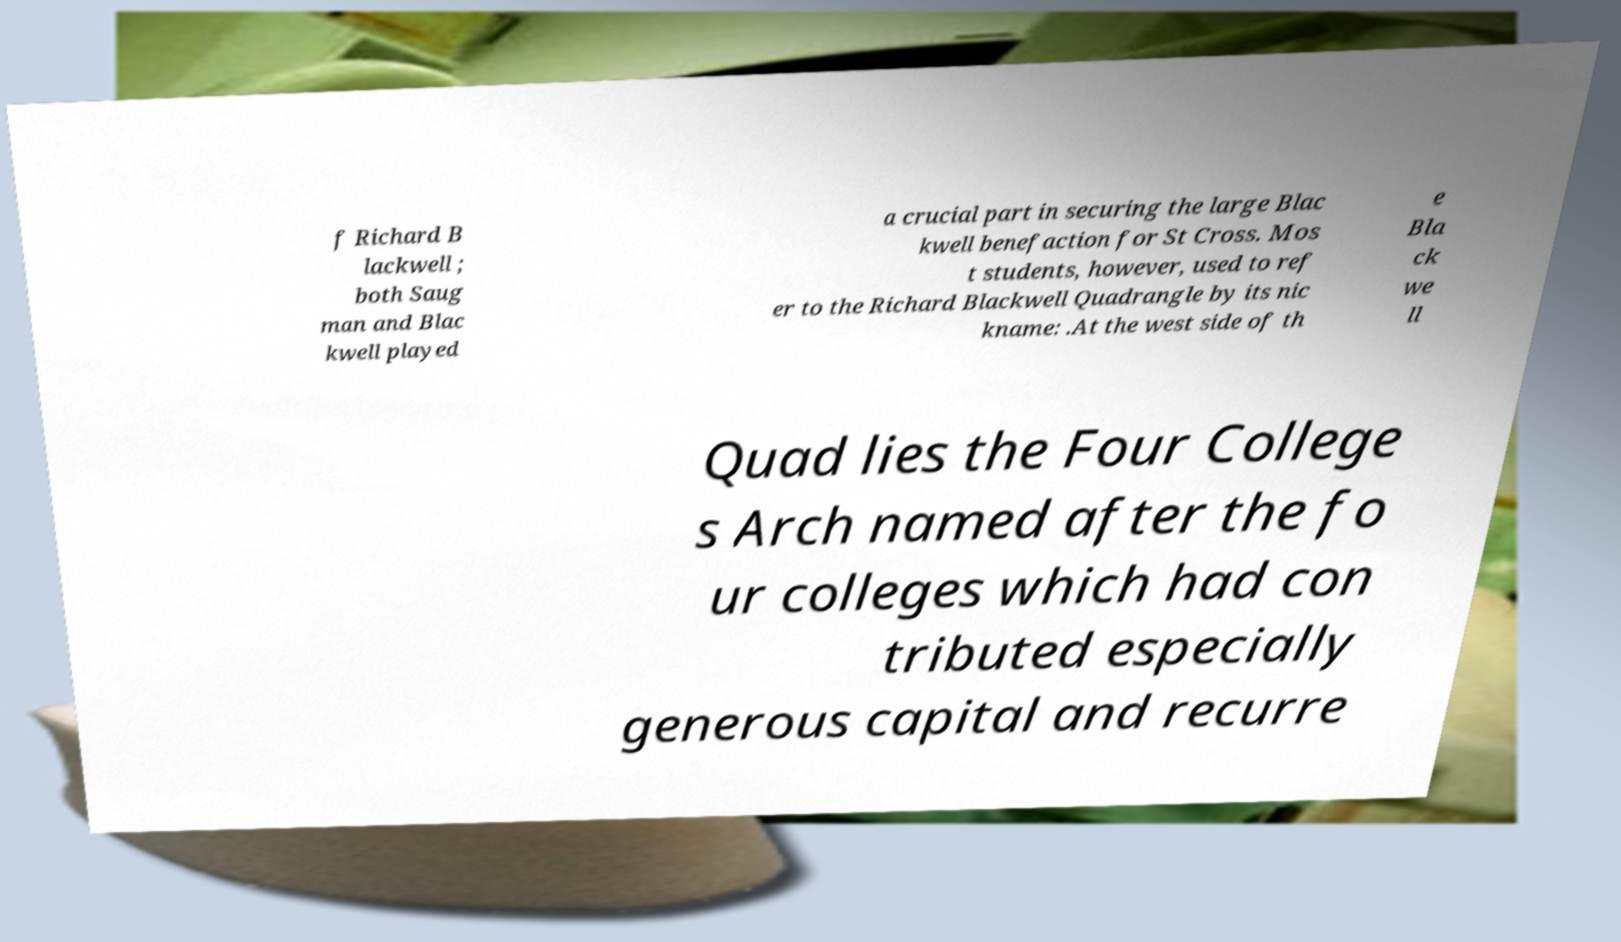Please read and relay the text visible in this image. What does it say? f Richard B lackwell ; both Saug man and Blac kwell played a crucial part in securing the large Blac kwell benefaction for St Cross. Mos t students, however, used to ref er to the Richard Blackwell Quadrangle by its nic kname: .At the west side of th e Bla ck we ll Quad lies the Four College s Arch named after the fo ur colleges which had con tributed especially generous capital and recurre 